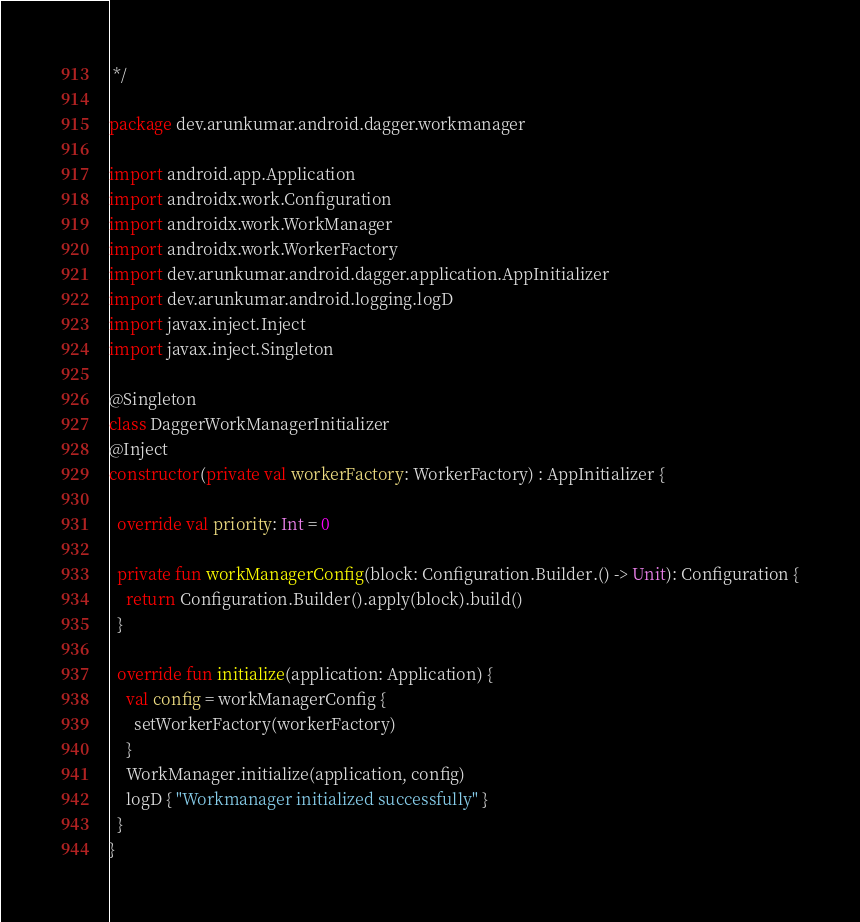<code> <loc_0><loc_0><loc_500><loc_500><_Kotlin_> */

package dev.arunkumar.android.dagger.workmanager

import android.app.Application
import androidx.work.Configuration
import androidx.work.WorkManager
import androidx.work.WorkerFactory
import dev.arunkumar.android.dagger.application.AppInitializer
import dev.arunkumar.android.logging.logD
import javax.inject.Inject
import javax.inject.Singleton

@Singleton
class DaggerWorkManagerInitializer
@Inject
constructor(private val workerFactory: WorkerFactory) : AppInitializer {

  override val priority: Int = 0

  private fun workManagerConfig(block: Configuration.Builder.() -> Unit): Configuration {
    return Configuration.Builder().apply(block).build()
  }

  override fun initialize(application: Application) {
    val config = workManagerConfig {
      setWorkerFactory(workerFactory)
    }
    WorkManager.initialize(application, config)
    logD { "Workmanager initialized successfully" }
  }
}
</code> 